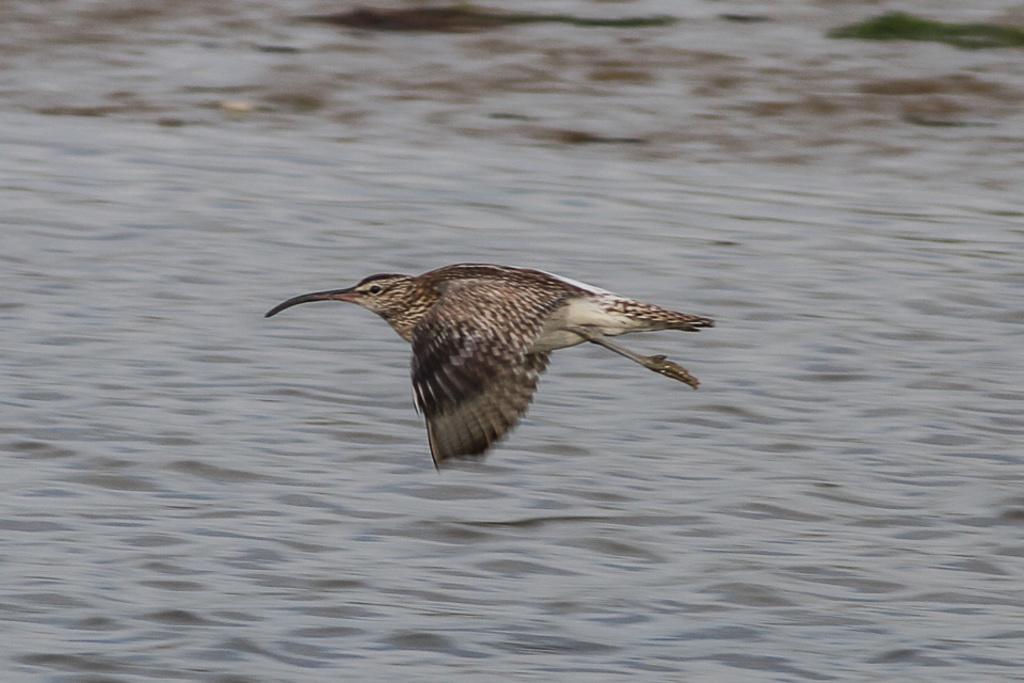What type of animal can be seen in the image? There is a bird in the image. What is the bird doing in the image? The bird is flying in the air. What natural element is visible in the image? There is water visible in the image. What type of apparel is the bird wearing in the image? Birds do not wear apparel, so there is no clothing visible on the bird in the image. How does the bird use the calculator in the image? There is no calculator present in the image; it only features a bird flying in the air and water. 